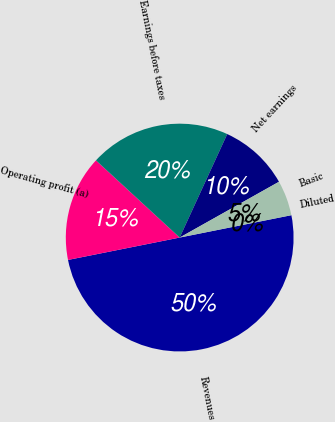<chart> <loc_0><loc_0><loc_500><loc_500><pie_chart><fcel>Revenues<fcel>Operating profit (a)<fcel>Earnings before taxes<fcel>Net earnings<fcel>Basic<fcel>Diluted<nl><fcel>50.0%<fcel>15.0%<fcel>20.0%<fcel>10.0%<fcel>5.0%<fcel>0.0%<nl></chart> 